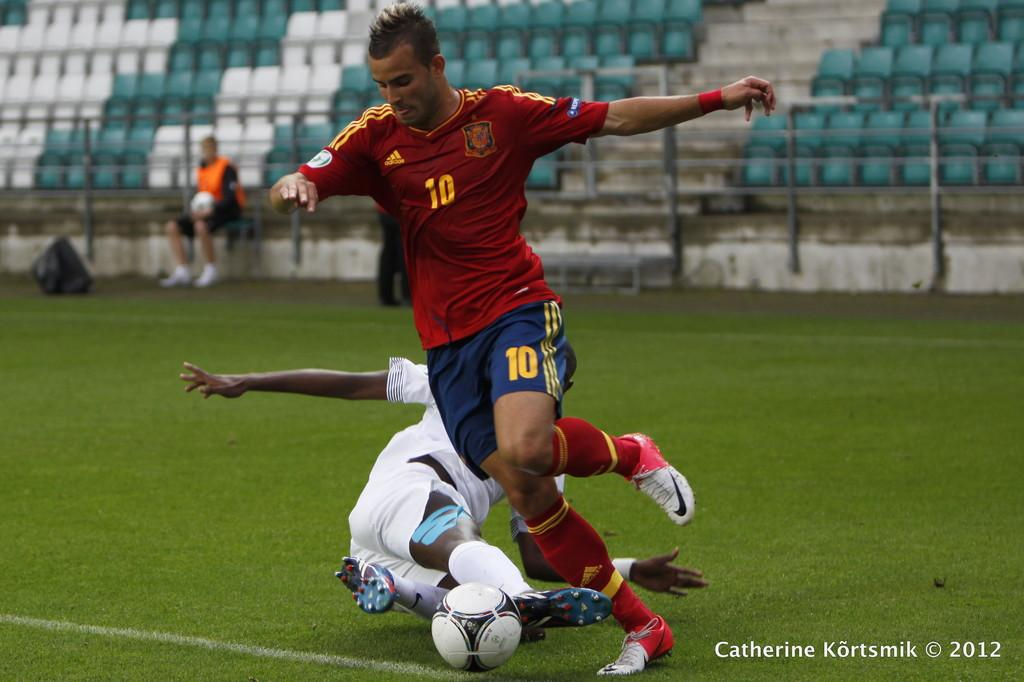Provide a one-sentence caption for the provided image. A soccer player number 10 getting ready to kick the ball. 